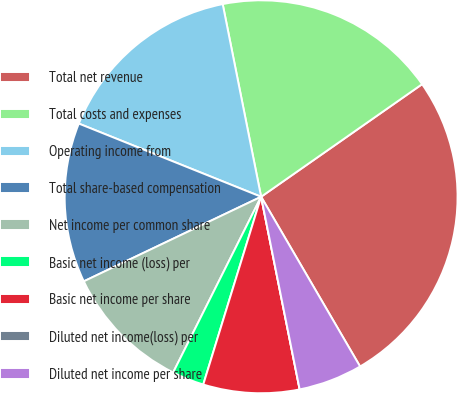Convert chart. <chart><loc_0><loc_0><loc_500><loc_500><pie_chart><fcel>Total net revenue<fcel>Total costs and expenses<fcel>Operating income from<fcel>Total share-based compensation<fcel>Net income per common share<fcel>Basic net income (loss) per<fcel>Basic net income per share<fcel>Diluted net income(loss) per<fcel>Diluted net income per share<nl><fcel>26.31%<fcel>18.42%<fcel>15.79%<fcel>13.16%<fcel>10.53%<fcel>2.63%<fcel>7.9%<fcel>0.0%<fcel>5.26%<nl></chart> 